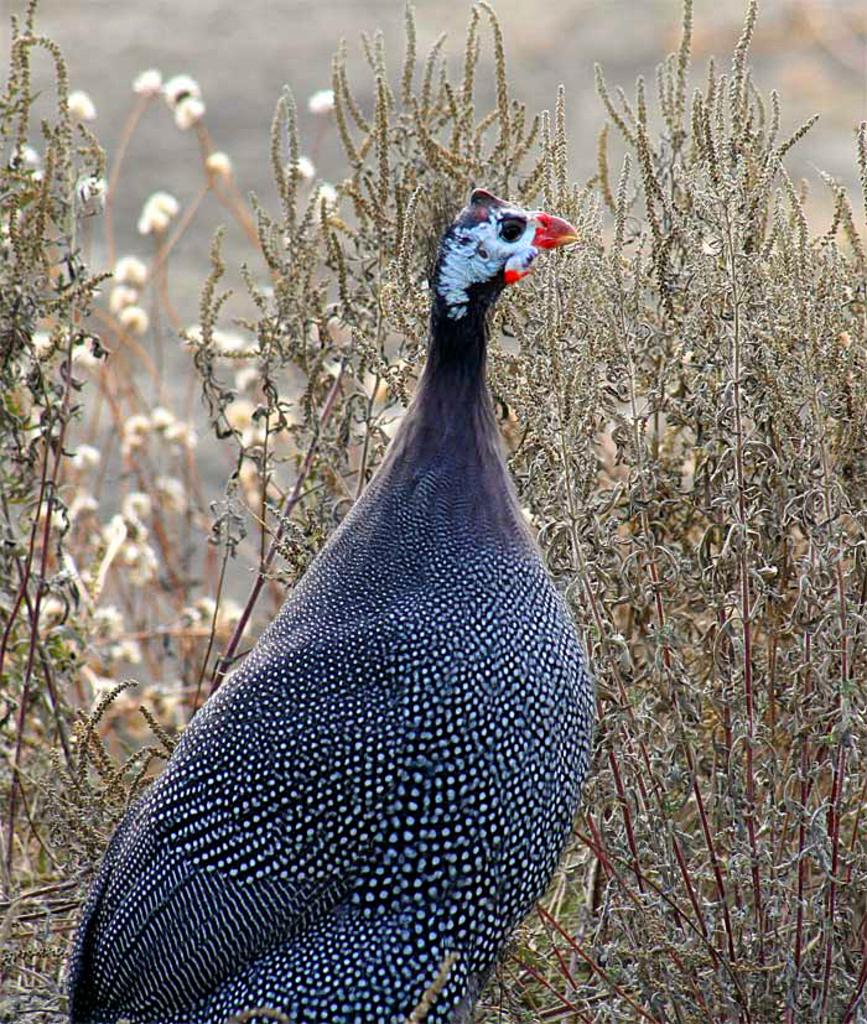What type of animal is in the picture? There is a bird in the picture. Can you describe the color of the bird? The bird is black and white in color. What can be seen in the background of the picture? There are plants visible in the background of the picture. What type of bit is the bird using to fly in the picture? Birds do not use bits to fly; they have wings that enable them to fly. 